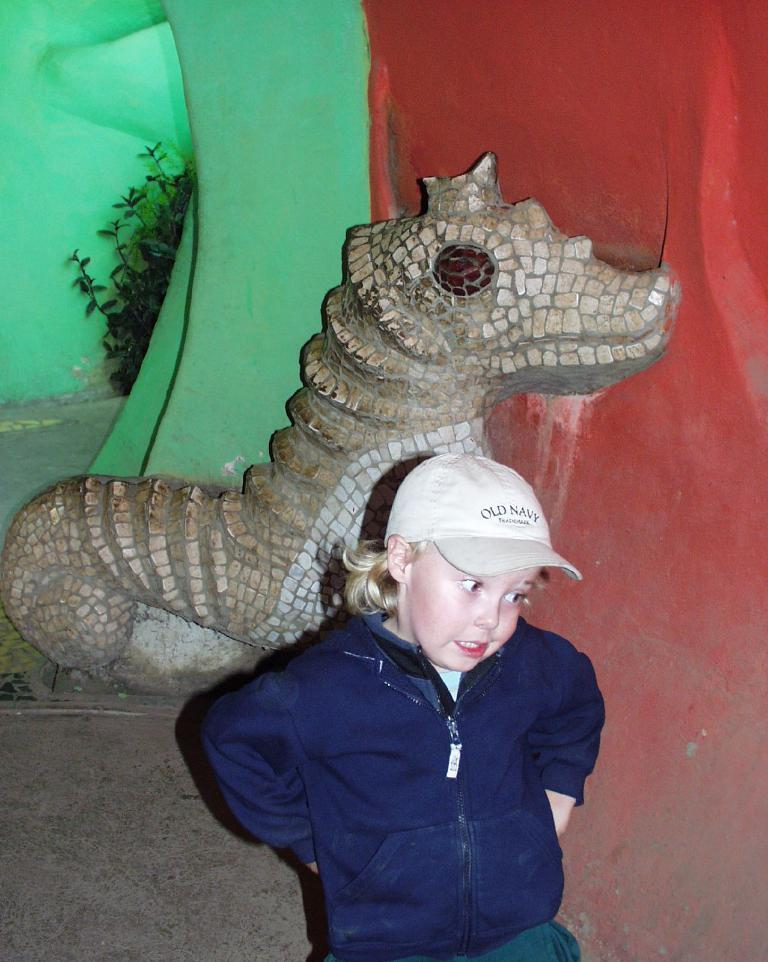What is the main subject of the image? The main subject of the image is a kid. What is the kid doing in the image? The kid is talking in the image. What is the kid wearing in the image? The kid is wearing a sweater and a cap in the image. What can be seen in the background of the image? There is a dragon statue in the background of the image. What type of vegetation is visible at the top of the image? There are plants visible at the top of the image. What type of shade is provided by the bushes in the image? There are no bushes present in the image, so no shade is provided by them. Is there any smoke visible in the image? There is no smoke visible in the image. 